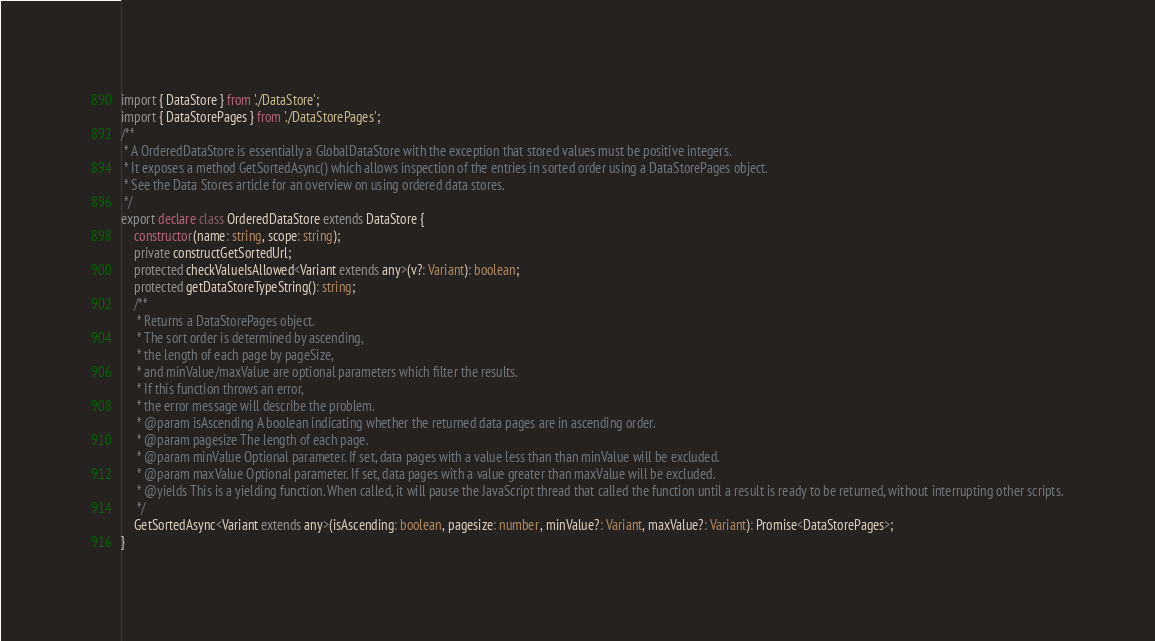Convert code to text. <code><loc_0><loc_0><loc_500><loc_500><_TypeScript_>import { DataStore } from './DataStore';
import { DataStorePages } from './DataStorePages';
/**
 * A OrderedDataStore is essentially a GlobalDataStore with the exception that stored values must be positive integers.
 * It exposes a method GetSortedAsync() which allows inspection of the entries in sorted order using a DataStorePages object.
 * See the Data Stores article for an overview on using ordered data stores.
 */
export declare class OrderedDataStore extends DataStore {
    constructor(name: string, scope: string);
    private constructGetSortedUrl;
    protected checkValueIsAllowed<Variant extends any>(v?: Variant): boolean;
    protected getDataStoreTypeString(): string;
    /**
     * Returns a DataStorePages object.
     * The sort order is determined by ascending,
     * the length of each page by pageSize,
     * and minValue/maxValue are optional parameters which filter the results.
     * If this function throws an error,
     * the error message will describe the problem.
     * @param isAscending A boolean indicating whether the returned data pages are in ascending order.
     * @param pagesize The length of each page.
     * @param minValue Optional parameter. If set, data pages with a value less than than minValue will be excluded.
     * @param maxValue Optional parameter. If set, data pages with a value greater than maxValue will be excluded.
     * @yields This is a yielding function. When called, it will pause the JavaScript thread that called the function until a result is ready to be returned, without interrupting other scripts.
     */
    GetSortedAsync<Variant extends any>(isAscending: boolean, pagesize: number, minValue?: Variant, maxValue?: Variant): Promise<DataStorePages>;
}
</code> 